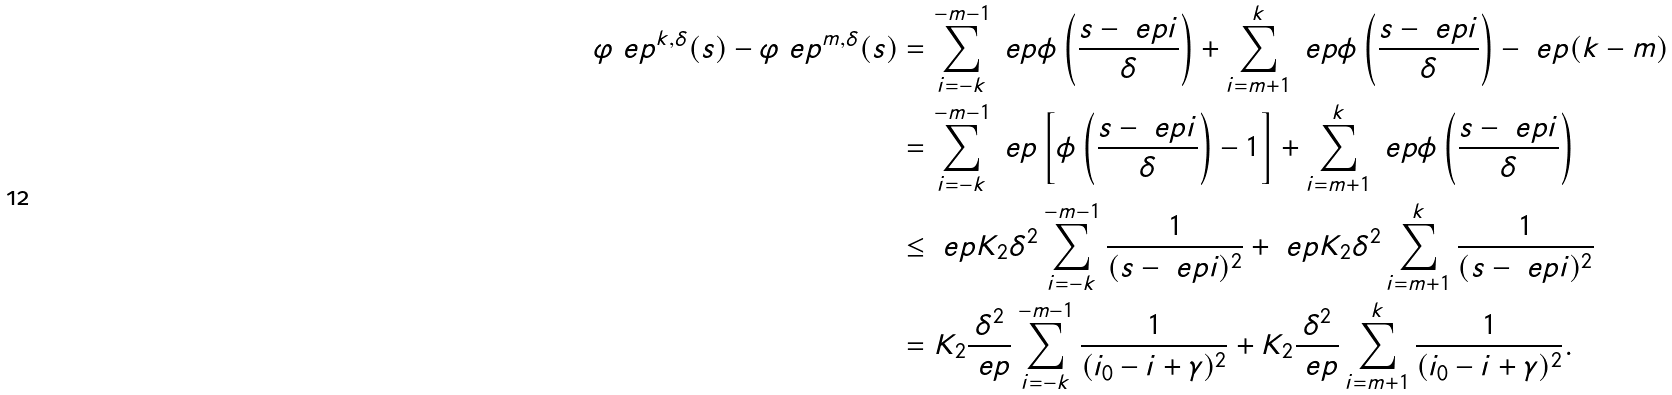Convert formula to latex. <formula><loc_0><loc_0><loc_500><loc_500>\varphi _ { \ } e p ^ { k , \delta } ( s ) - \varphi _ { \ } e p ^ { m , \delta } ( s ) & = \sum _ { i = - k } ^ { - m - 1 } \ e p \phi \left ( \frac { s - \ e p i } { \delta } \right ) + \sum _ { i = m + 1 } ^ { k } \ e p \phi \left ( \frac { s - \ e p i } { \delta } \right ) - \ e p ( k - m ) \\ & = \sum _ { i = - k } ^ { - m - 1 } \ e p \left [ \phi \left ( \frac { s - \ e p i } { \delta } \right ) - 1 \right ] + \sum _ { i = m + 1 } ^ { k } \ e p \phi \left ( \frac { s - \ e p i } { \delta } \right ) \\ & \leq \ e p K _ { 2 } \delta ^ { 2 } \sum _ { i = - k } ^ { - m - 1 } \frac { 1 } { ( s - \ e p i ) ^ { 2 } } + \ e p K _ { 2 } \delta ^ { 2 } \sum _ { i = m + 1 } ^ { k } \frac { 1 } { ( s - \ e p i ) ^ { 2 } } \\ & = K _ { 2 } \frac { \delta ^ { 2 } } { \ e p } \sum _ { i = - k } ^ { - m - 1 } \frac { 1 } { ( i _ { 0 } - i + \gamma ) ^ { 2 } } + K _ { 2 } \frac { \delta ^ { 2 } } { \ e p } \sum _ { i = m + 1 } ^ { k } \frac { 1 } { ( i _ { 0 } - i + \gamma ) ^ { 2 } } .</formula> 